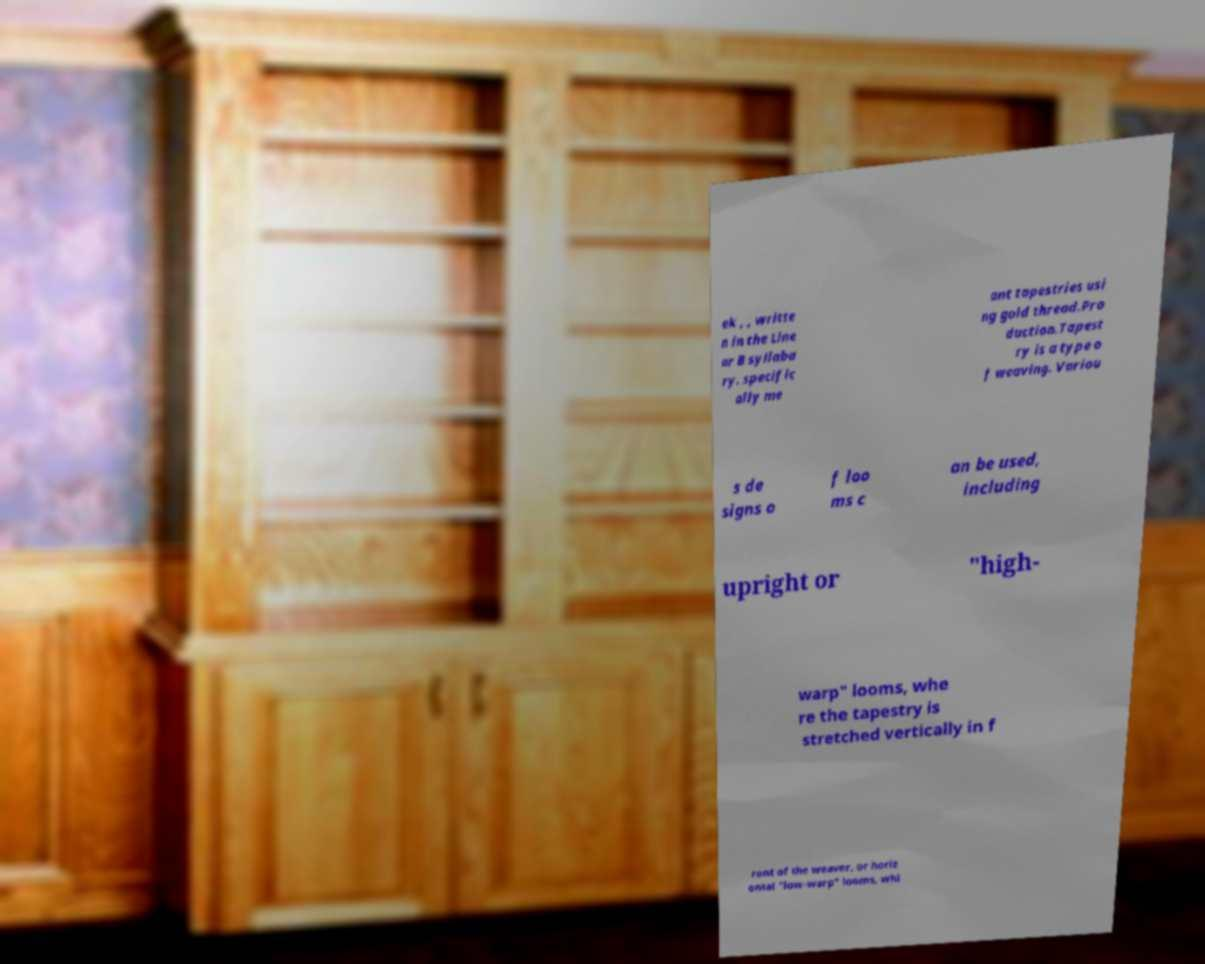Could you extract and type out the text from this image? ek , , writte n in the Line ar B syllaba ry. specific ally me ant tapestries usi ng gold thread.Pro duction.Tapest ry is a type o f weaving. Variou s de signs o f loo ms c an be used, including upright or "high- warp" looms, whe re the tapestry is stretched vertically in f ront of the weaver, or horiz ontal "low-warp" looms, whi 